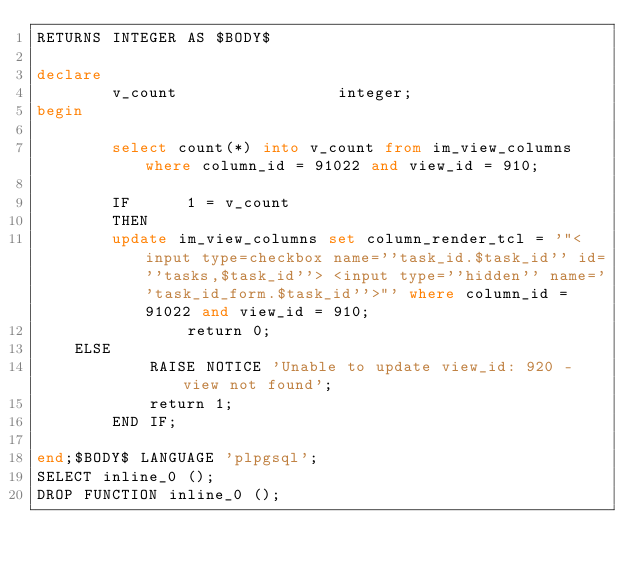Convert code to text. <code><loc_0><loc_0><loc_500><loc_500><_SQL_>RETURNS INTEGER AS $BODY$

declare
        v_count                 integer;
begin

        select count(*) into v_count from im_view_columns where column_id = 91022 and view_id = 910;

        IF      1 = v_count
        THEN
		update im_view_columns set column_render_tcl = '"<input type=checkbox name=''task_id.$task_id'' id=''tasks,$task_id''> <input type=''hidden'' name=''task_id_form.$task_id''>"' where column_id = 91022 and view_id = 910;
                return 0;
	ELSE 	
	     	RAISE NOTICE 'Unable to update view_id: 920 - view not found';
	        return 1;	     
        END IF;

end;$BODY$ LANGUAGE 'plpgsql';
SELECT inline_0 ();
DROP FUNCTION inline_0 ();
</code> 